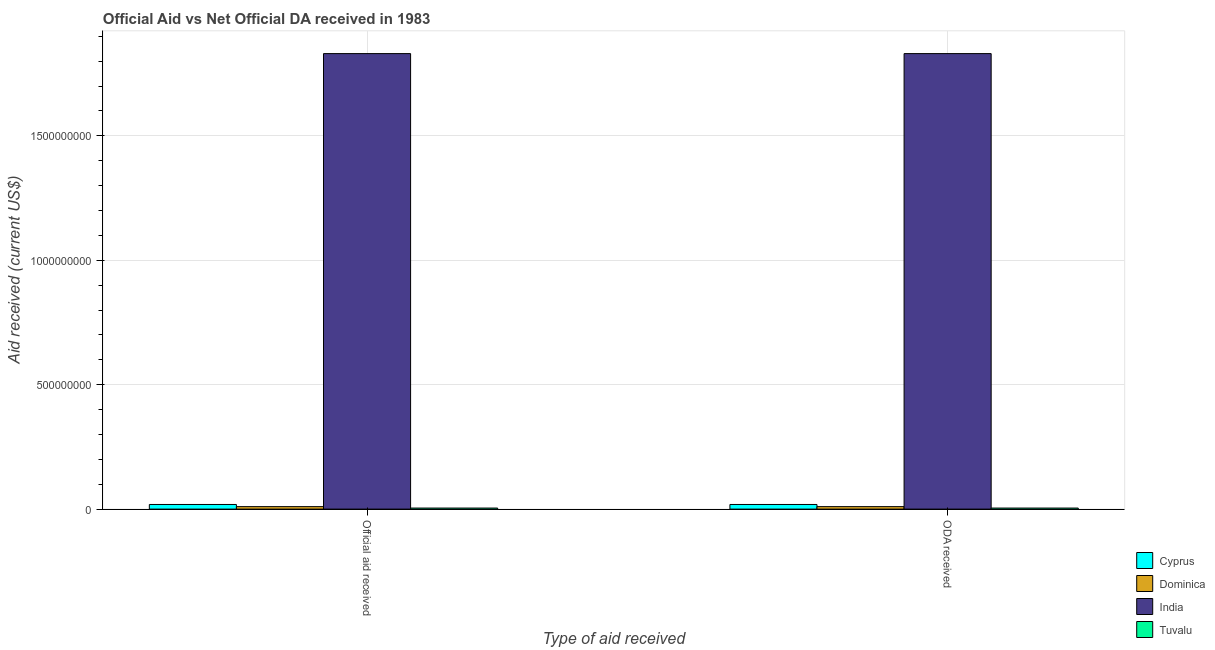How many bars are there on the 1st tick from the left?
Keep it short and to the point. 4. What is the label of the 2nd group of bars from the left?
Provide a succinct answer. ODA received. What is the official aid received in Dominica?
Your response must be concise. 9.92e+06. Across all countries, what is the maximum oda received?
Keep it short and to the point. 1.83e+09. Across all countries, what is the minimum official aid received?
Provide a succinct answer. 4.21e+06. In which country was the official aid received minimum?
Provide a succinct answer. Tuvalu. What is the total official aid received in the graph?
Make the answer very short. 1.86e+09. What is the difference between the official aid received in Dominica and that in India?
Your response must be concise. -1.82e+09. What is the difference between the official aid received in India and the oda received in Dominica?
Provide a short and direct response. 1.82e+09. What is the average oda received per country?
Your answer should be compact. 4.66e+08. What is the difference between the official aid received and oda received in Tuvalu?
Your answer should be very brief. 0. What is the ratio of the oda received in India to that in Dominica?
Your answer should be very brief. 184.53. What does the 1st bar from the left in Official aid received represents?
Your answer should be very brief. Cyprus. What does the 3rd bar from the right in ODA received represents?
Ensure brevity in your answer.  Dominica. Are all the bars in the graph horizontal?
Ensure brevity in your answer.  No. What is the difference between two consecutive major ticks on the Y-axis?
Your response must be concise. 5.00e+08. Are the values on the major ticks of Y-axis written in scientific E-notation?
Make the answer very short. No. Does the graph contain any zero values?
Your answer should be compact. No. Does the graph contain grids?
Provide a succinct answer. Yes. Where does the legend appear in the graph?
Ensure brevity in your answer.  Bottom right. How many legend labels are there?
Offer a very short reply. 4. How are the legend labels stacked?
Your answer should be compact. Vertical. What is the title of the graph?
Offer a terse response. Official Aid vs Net Official DA received in 1983 . What is the label or title of the X-axis?
Your answer should be compact. Type of aid received. What is the label or title of the Y-axis?
Provide a short and direct response. Aid received (current US$). What is the Aid received (current US$) of Cyprus in Official aid received?
Your answer should be compact. 1.86e+07. What is the Aid received (current US$) in Dominica in Official aid received?
Your answer should be compact. 9.92e+06. What is the Aid received (current US$) in India in Official aid received?
Keep it short and to the point. 1.83e+09. What is the Aid received (current US$) in Tuvalu in Official aid received?
Provide a short and direct response. 4.21e+06. What is the Aid received (current US$) in Cyprus in ODA received?
Your response must be concise. 1.86e+07. What is the Aid received (current US$) of Dominica in ODA received?
Your answer should be compact. 9.92e+06. What is the Aid received (current US$) in India in ODA received?
Your response must be concise. 1.83e+09. What is the Aid received (current US$) of Tuvalu in ODA received?
Your answer should be compact. 4.21e+06. Across all Type of aid received, what is the maximum Aid received (current US$) in Cyprus?
Offer a terse response. 1.86e+07. Across all Type of aid received, what is the maximum Aid received (current US$) of Dominica?
Ensure brevity in your answer.  9.92e+06. Across all Type of aid received, what is the maximum Aid received (current US$) in India?
Your answer should be very brief. 1.83e+09. Across all Type of aid received, what is the maximum Aid received (current US$) in Tuvalu?
Your answer should be very brief. 4.21e+06. Across all Type of aid received, what is the minimum Aid received (current US$) of Cyprus?
Ensure brevity in your answer.  1.86e+07. Across all Type of aid received, what is the minimum Aid received (current US$) of Dominica?
Keep it short and to the point. 9.92e+06. Across all Type of aid received, what is the minimum Aid received (current US$) in India?
Offer a terse response. 1.83e+09. Across all Type of aid received, what is the minimum Aid received (current US$) in Tuvalu?
Ensure brevity in your answer.  4.21e+06. What is the total Aid received (current US$) in Cyprus in the graph?
Your response must be concise. 3.71e+07. What is the total Aid received (current US$) in Dominica in the graph?
Provide a succinct answer. 1.98e+07. What is the total Aid received (current US$) in India in the graph?
Give a very brief answer. 3.66e+09. What is the total Aid received (current US$) of Tuvalu in the graph?
Offer a very short reply. 8.42e+06. What is the difference between the Aid received (current US$) in Cyprus in Official aid received and that in ODA received?
Make the answer very short. 0. What is the difference between the Aid received (current US$) of India in Official aid received and that in ODA received?
Make the answer very short. 0. What is the difference between the Aid received (current US$) in Cyprus in Official aid received and the Aid received (current US$) in Dominica in ODA received?
Provide a succinct answer. 8.65e+06. What is the difference between the Aid received (current US$) in Cyprus in Official aid received and the Aid received (current US$) in India in ODA received?
Offer a terse response. -1.81e+09. What is the difference between the Aid received (current US$) of Cyprus in Official aid received and the Aid received (current US$) of Tuvalu in ODA received?
Provide a short and direct response. 1.44e+07. What is the difference between the Aid received (current US$) of Dominica in Official aid received and the Aid received (current US$) of India in ODA received?
Provide a succinct answer. -1.82e+09. What is the difference between the Aid received (current US$) of Dominica in Official aid received and the Aid received (current US$) of Tuvalu in ODA received?
Ensure brevity in your answer.  5.71e+06. What is the difference between the Aid received (current US$) in India in Official aid received and the Aid received (current US$) in Tuvalu in ODA received?
Keep it short and to the point. 1.83e+09. What is the average Aid received (current US$) in Cyprus per Type of aid received?
Your response must be concise. 1.86e+07. What is the average Aid received (current US$) in Dominica per Type of aid received?
Offer a terse response. 9.92e+06. What is the average Aid received (current US$) of India per Type of aid received?
Provide a short and direct response. 1.83e+09. What is the average Aid received (current US$) in Tuvalu per Type of aid received?
Your answer should be very brief. 4.21e+06. What is the difference between the Aid received (current US$) of Cyprus and Aid received (current US$) of Dominica in Official aid received?
Provide a short and direct response. 8.65e+06. What is the difference between the Aid received (current US$) in Cyprus and Aid received (current US$) in India in Official aid received?
Your answer should be very brief. -1.81e+09. What is the difference between the Aid received (current US$) in Cyprus and Aid received (current US$) in Tuvalu in Official aid received?
Offer a very short reply. 1.44e+07. What is the difference between the Aid received (current US$) in Dominica and Aid received (current US$) in India in Official aid received?
Your response must be concise. -1.82e+09. What is the difference between the Aid received (current US$) of Dominica and Aid received (current US$) of Tuvalu in Official aid received?
Make the answer very short. 5.71e+06. What is the difference between the Aid received (current US$) of India and Aid received (current US$) of Tuvalu in Official aid received?
Provide a short and direct response. 1.83e+09. What is the difference between the Aid received (current US$) of Cyprus and Aid received (current US$) of Dominica in ODA received?
Provide a short and direct response. 8.65e+06. What is the difference between the Aid received (current US$) of Cyprus and Aid received (current US$) of India in ODA received?
Offer a terse response. -1.81e+09. What is the difference between the Aid received (current US$) in Cyprus and Aid received (current US$) in Tuvalu in ODA received?
Offer a very short reply. 1.44e+07. What is the difference between the Aid received (current US$) of Dominica and Aid received (current US$) of India in ODA received?
Give a very brief answer. -1.82e+09. What is the difference between the Aid received (current US$) in Dominica and Aid received (current US$) in Tuvalu in ODA received?
Your answer should be compact. 5.71e+06. What is the difference between the Aid received (current US$) in India and Aid received (current US$) in Tuvalu in ODA received?
Make the answer very short. 1.83e+09. What is the ratio of the Aid received (current US$) of Cyprus in Official aid received to that in ODA received?
Your response must be concise. 1. What is the ratio of the Aid received (current US$) of Dominica in Official aid received to that in ODA received?
Your answer should be compact. 1. What is the ratio of the Aid received (current US$) of India in Official aid received to that in ODA received?
Offer a very short reply. 1. What is the ratio of the Aid received (current US$) in Tuvalu in Official aid received to that in ODA received?
Provide a short and direct response. 1. What is the difference between the highest and the second highest Aid received (current US$) of Cyprus?
Provide a short and direct response. 0. What is the difference between the highest and the second highest Aid received (current US$) of Dominica?
Give a very brief answer. 0. What is the difference between the highest and the lowest Aid received (current US$) of India?
Ensure brevity in your answer.  0. What is the difference between the highest and the lowest Aid received (current US$) in Tuvalu?
Offer a very short reply. 0. 